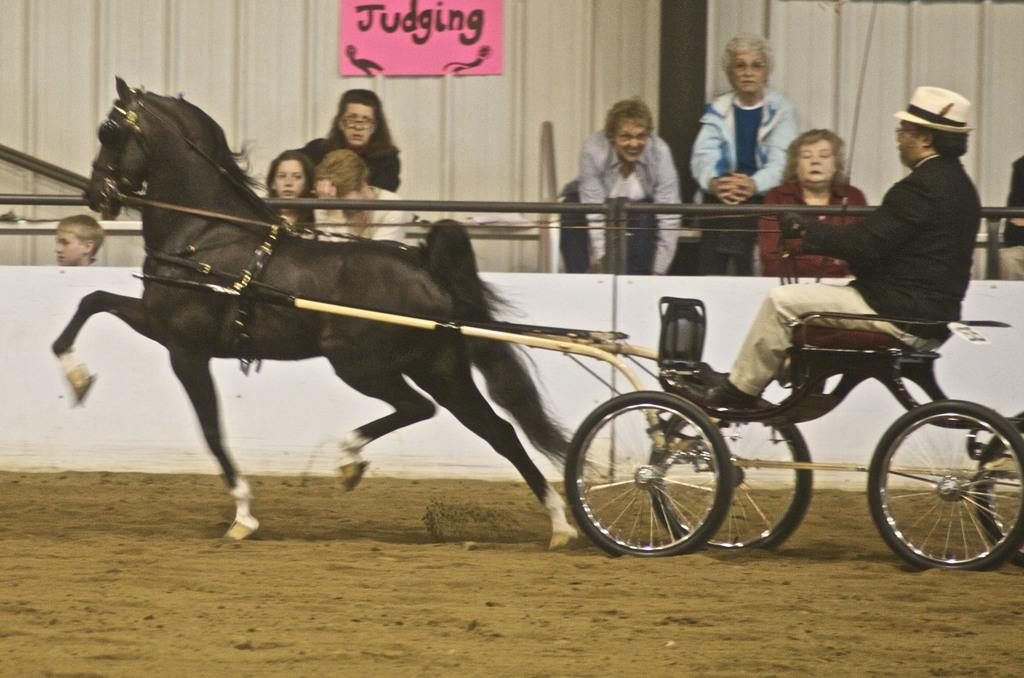What are the persons in the image wearing? The persons in the image are wearing clothes. Can you describe the person on the right side of the image? The person on the right side of the image is sitting on a horse cart. What is located at the top of the image? There is a board at the top of the image. How many fingers can be seen holding the bucket in the image? There is no bucket or fingers present in the image. What type of rat is visible in the image? There is no rat present in the image. 